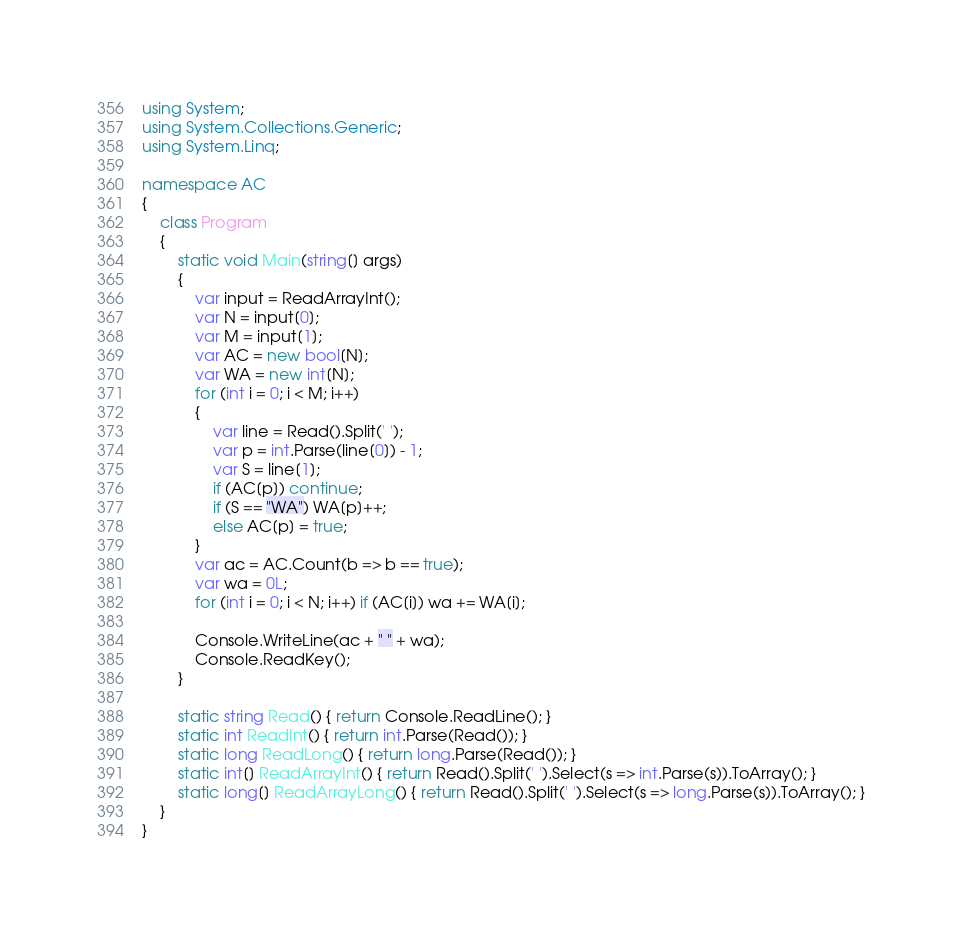<code> <loc_0><loc_0><loc_500><loc_500><_C#_>using System;
using System.Collections.Generic;
using System.Linq;

namespace AC
{
    class Program
    {
        static void Main(string[] args)
        {
            var input = ReadArrayInt();
            var N = input[0];
            var M = input[1];
            var AC = new bool[N];
            var WA = new int[N];
            for (int i = 0; i < M; i++)
            {
                var line = Read().Split(' ');
                var p = int.Parse(line[0]) - 1;
                var S = line[1];
                if (AC[p]) continue;
                if (S == "WA") WA[p]++;
                else AC[p] = true;
            }
            var ac = AC.Count(b => b == true);
            var wa = 0L;
            for (int i = 0; i < N; i++) if (AC[i]) wa += WA[i];

            Console.WriteLine(ac + " " + wa);
            Console.ReadKey();
        }

        static string Read() { return Console.ReadLine(); }
        static int ReadInt() { return int.Parse(Read()); }
        static long ReadLong() { return long.Parse(Read()); }
        static int[] ReadArrayInt() { return Read().Split(' ').Select(s => int.Parse(s)).ToArray(); }
        static long[] ReadArrayLong() { return Read().Split(' ').Select(s => long.Parse(s)).ToArray(); }
    }
}</code> 